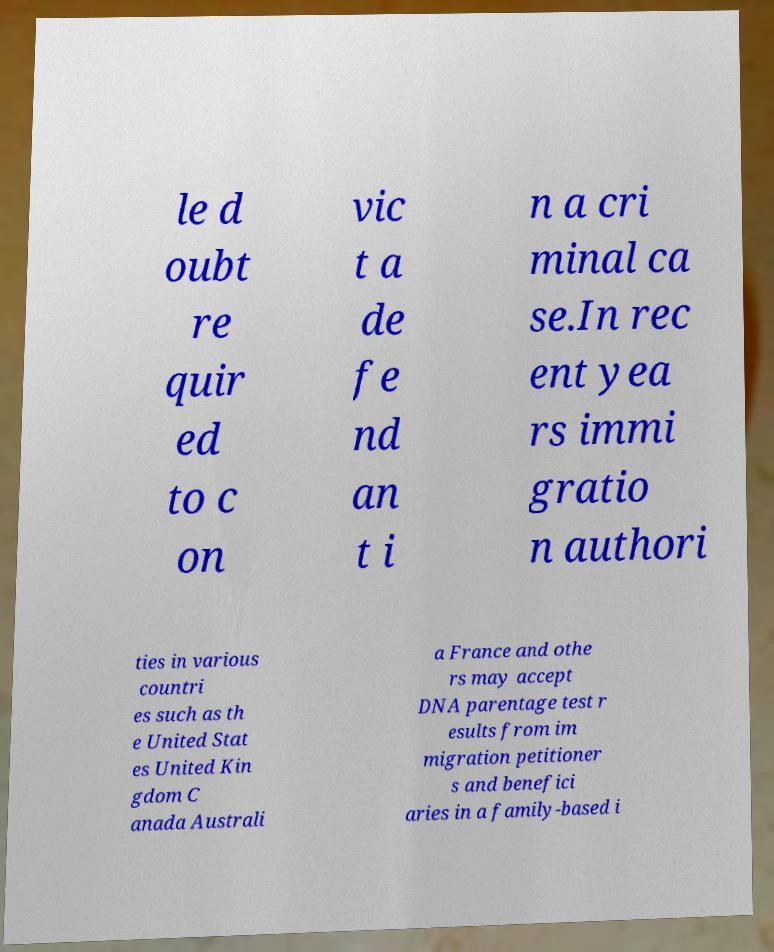Please read and relay the text visible in this image. What does it say? le d oubt re quir ed to c on vic t a de fe nd an t i n a cri minal ca se.In rec ent yea rs immi gratio n authori ties in various countri es such as th e United Stat es United Kin gdom C anada Australi a France and othe rs may accept DNA parentage test r esults from im migration petitioner s and benefici aries in a family-based i 